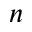<formula> <loc_0><loc_0><loc_500><loc_500>n</formula> 